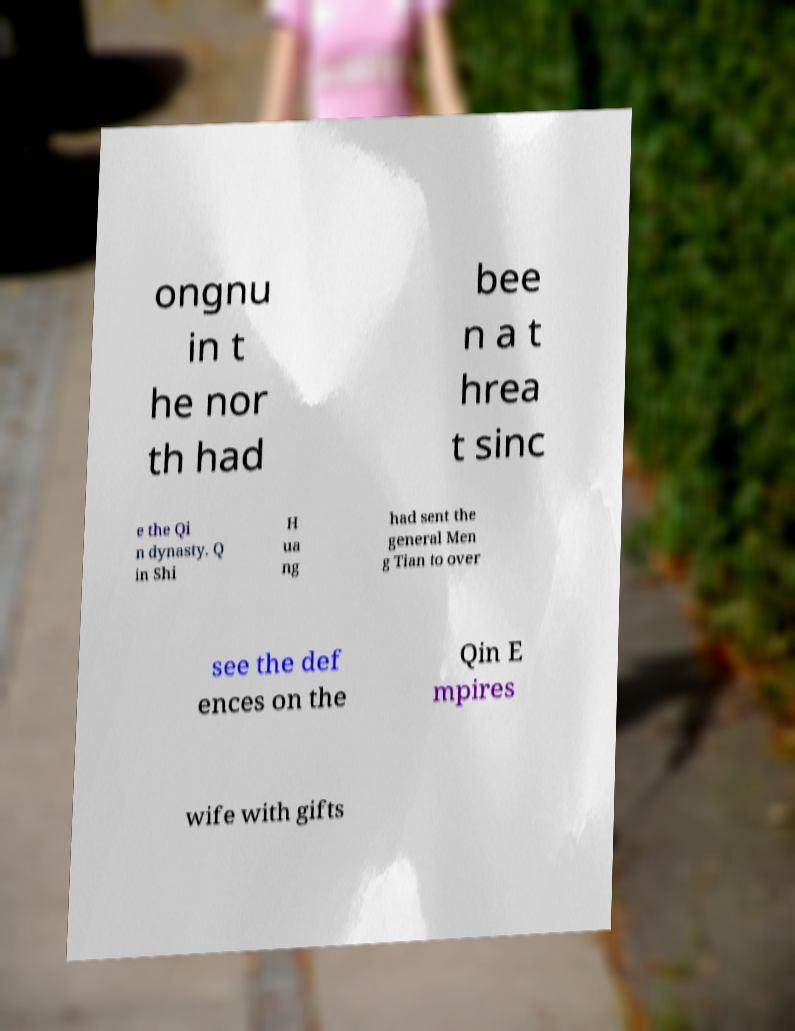Please read and relay the text visible in this image. What does it say? ongnu in t he nor th had bee n a t hrea t sinc e the Qi n dynasty. Q in Shi H ua ng had sent the general Men g Tian to over see the def ences on the Qin E mpires wife with gifts 